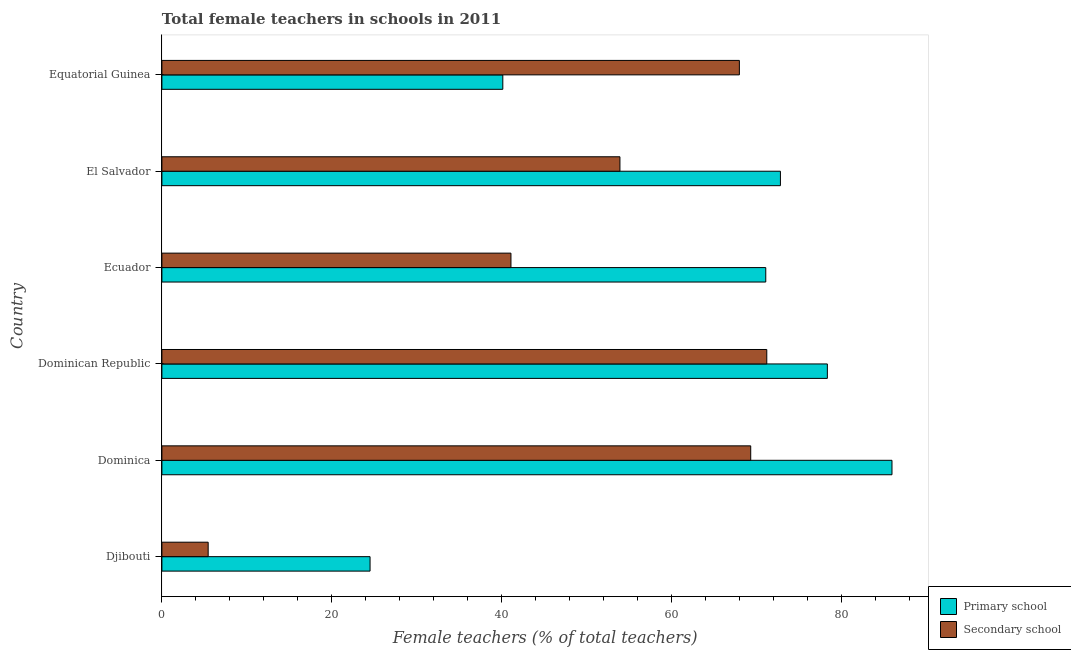How many different coloured bars are there?
Keep it short and to the point. 2. Are the number of bars on each tick of the Y-axis equal?
Your answer should be very brief. Yes. What is the label of the 2nd group of bars from the top?
Ensure brevity in your answer.  El Salvador. What is the percentage of female teachers in secondary schools in Equatorial Guinea?
Make the answer very short. 67.95. Across all countries, what is the maximum percentage of female teachers in primary schools?
Your answer should be compact. 85.91. Across all countries, what is the minimum percentage of female teachers in primary schools?
Provide a succinct answer. 24.49. In which country was the percentage of female teachers in secondary schools maximum?
Make the answer very short. Dominican Republic. In which country was the percentage of female teachers in secondary schools minimum?
Your response must be concise. Djibouti. What is the total percentage of female teachers in primary schools in the graph?
Offer a very short reply. 372.67. What is the difference between the percentage of female teachers in primary schools in Dominica and that in Equatorial Guinea?
Offer a terse response. 45.79. What is the difference between the percentage of female teachers in primary schools in Dominican Republic and the percentage of female teachers in secondary schools in Djibouti?
Make the answer very short. 72.86. What is the average percentage of female teachers in secondary schools per country?
Your answer should be very brief. 51.47. What is the difference between the percentage of female teachers in secondary schools and percentage of female teachers in primary schools in Equatorial Guinea?
Ensure brevity in your answer.  27.84. In how many countries, is the percentage of female teachers in primary schools greater than 44 %?
Provide a short and direct response. 4. What is the ratio of the percentage of female teachers in primary schools in Dominican Republic to that in Equatorial Guinea?
Provide a succinct answer. 1.95. What is the difference between the highest and the second highest percentage of female teachers in primary schools?
Your response must be concise. 7.61. What is the difference between the highest and the lowest percentage of female teachers in secondary schools?
Your response must be concise. 65.73. Is the sum of the percentage of female teachers in primary schools in Djibouti and El Salvador greater than the maximum percentage of female teachers in secondary schools across all countries?
Offer a terse response. Yes. What does the 1st bar from the top in Dominican Republic represents?
Keep it short and to the point. Secondary school. What does the 2nd bar from the bottom in Djibouti represents?
Your response must be concise. Secondary school. What is the difference between two consecutive major ticks on the X-axis?
Provide a short and direct response. 20. Does the graph contain grids?
Your response must be concise. No. What is the title of the graph?
Your answer should be compact. Total female teachers in schools in 2011. Does "Food and tobacco" appear as one of the legend labels in the graph?
Provide a short and direct response. No. What is the label or title of the X-axis?
Ensure brevity in your answer.  Female teachers (% of total teachers). What is the Female teachers (% of total teachers) in Primary school in Djibouti?
Provide a short and direct response. 24.49. What is the Female teachers (% of total teachers) of Secondary school in Djibouti?
Provide a short and direct response. 5.44. What is the Female teachers (% of total teachers) in Primary school in Dominica?
Offer a terse response. 85.91. What is the Female teachers (% of total teachers) of Secondary school in Dominica?
Ensure brevity in your answer.  69.29. What is the Female teachers (% of total teachers) in Primary school in Dominican Republic?
Your answer should be very brief. 78.31. What is the Female teachers (% of total teachers) of Secondary school in Dominican Republic?
Your response must be concise. 71.18. What is the Female teachers (% of total teachers) in Primary school in Ecuador?
Your response must be concise. 71.06. What is the Female teachers (% of total teachers) in Secondary school in Ecuador?
Offer a terse response. 41.07. What is the Female teachers (% of total teachers) of Primary school in El Salvador?
Ensure brevity in your answer.  72.78. What is the Female teachers (% of total teachers) of Secondary school in El Salvador?
Give a very brief answer. 53.9. What is the Female teachers (% of total teachers) in Primary school in Equatorial Guinea?
Your answer should be very brief. 40.12. What is the Female teachers (% of total teachers) in Secondary school in Equatorial Guinea?
Keep it short and to the point. 67.95. Across all countries, what is the maximum Female teachers (% of total teachers) in Primary school?
Provide a succinct answer. 85.91. Across all countries, what is the maximum Female teachers (% of total teachers) of Secondary school?
Make the answer very short. 71.18. Across all countries, what is the minimum Female teachers (% of total teachers) of Primary school?
Offer a terse response. 24.49. Across all countries, what is the minimum Female teachers (% of total teachers) in Secondary school?
Provide a short and direct response. 5.44. What is the total Female teachers (% of total teachers) of Primary school in the graph?
Make the answer very short. 372.67. What is the total Female teachers (% of total teachers) of Secondary school in the graph?
Provide a succinct answer. 308.83. What is the difference between the Female teachers (% of total teachers) in Primary school in Djibouti and that in Dominica?
Offer a very short reply. -61.42. What is the difference between the Female teachers (% of total teachers) in Secondary school in Djibouti and that in Dominica?
Your answer should be compact. -63.84. What is the difference between the Female teachers (% of total teachers) in Primary school in Djibouti and that in Dominican Republic?
Make the answer very short. -53.81. What is the difference between the Female teachers (% of total teachers) of Secondary school in Djibouti and that in Dominican Republic?
Your response must be concise. -65.73. What is the difference between the Female teachers (% of total teachers) of Primary school in Djibouti and that in Ecuador?
Provide a short and direct response. -46.56. What is the difference between the Female teachers (% of total teachers) of Secondary school in Djibouti and that in Ecuador?
Keep it short and to the point. -35.63. What is the difference between the Female teachers (% of total teachers) in Primary school in Djibouti and that in El Salvador?
Make the answer very short. -48.29. What is the difference between the Female teachers (% of total teachers) of Secondary school in Djibouti and that in El Salvador?
Offer a terse response. -48.45. What is the difference between the Female teachers (% of total teachers) of Primary school in Djibouti and that in Equatorial Guinea?
Offer a very short reply. -15.62. What is the difference between the Female teachers (% of total teachers) in Secondary school in Djibouti and that in Equatorial Guinea?
Provide a short and direct response. -62.51. What is the difference between the Female teachers (% of total teachers) of Primary school in Dominica and that in Dominican Republic?
Give a very brief answer. 7.6. What is the difference between the Female teachers (% of total teachers) of Secondary school in Dominica and that in Dominican Republic?
Your answer should be very brief. -1.89. What is the difference between the Female teachers (% of total teachers) in Primary school in Dominica and that in Ecuador?
Provide a short and direct response. 14.85. What is the difference between the Female teachers (% of total teachers) in Secondary school in Dominica and that in Ecuador?
Provide a succinct answer. 28.21. What is the difference between the Female teachers (% of total teachers) in Primary school in Dominica and that in El Salvador?
Make the answer very short. 13.13. What is the difference between the Female teachers (% of total teachers) of Secondary school in Dominica and that in El Salvador?
Ensure brevity in your answer.  15.39. What is the difference between the Female teachers (% of total teachers) of Primary school in Dominica and that in Equatorial Guinea?
Give a very brief answer. 45.79. What is the difference between the Female teachers (% of total teachers) in Secondary school in Dominica and that in Equatorial Guinea?
Provide a short and direct response. 1.33. What is the difference between the Female teachers (% of total teachers) of Primary school in Dominican Republic and that in Ecuador?
Your answer should be compact. 7.25. What is the difference between the Female teachers (% of total teachers) in Secondary school in Dominican Republic and that in Ecuador?
Ensure brevity in your answer.  30.1. What is the difference between the Female teachers (% of total teachers) of Primary school in Dominican Republic and that in El Salvador?
Keep it short and to the point. 5.52. What is the difference between the Female teachers (% of total teachers) of Secondary school in Dominican Republic and that in El Salvador?
Give a very brief answer. 17.28. What is the difference between the Female teachers (% of total teachers) of Primary school in Dominican Republic and that in Equatorial Guinea?
Offer a terse response. 38.19. What is the difference between the Female teachers (% of total teachers) of Secondary school in Dominican Republic and that in Equatorial Guinea?
Keep it short and to the point. 3.22. What is the difference between the Female teachers (% of total teachers) of Primary school in Ecuador and that in El Salvador?
Your response must be concise. -1.72. What is the difference between the Female teachers (% of total teachers) in Secondary school in Ecuador and that in El Salvador?
Give a very brief answer. -12.82. What is the difference between the Female teachers (% of total teachers) in Primary school in Ecuador and that in Equatorial Guinea?
Provide a succinct answer. 30.94. What is the difference between the Female teachers (% of total teachers) in Secondary school in Ecuador and that in Equatorial Guinea?
Provide a short and direct response. -26.88. What is the difference between the Female teachers (% of total teachers) of Primary school in El Salvador and that in Equatorial Guinea?
Your response must be concise. 32.67. What is the difference between the Female teachers (% of total teachers) of Secondary school in El Salvador and that in Equatorial Guinea?
Keep it short and to the point. -14.05. What is the difference between the Female teachers (% of total teachers) of Primary school in Djibouti and the Female teachers (% of total teachers) of Secondary school in Dominica?
Offer a terse response. -44.79. What is the difference between the Female teachers (% of total teachers) in Primary school in Djibouti and the Female teachers (% of total teachers) in Secondary school in Dominican Republic?
Your answer should be compact. -46.68. What is the difference between the Female teachers (% of total teachers) in Primary school in Djibouti and the Female teachers (% of total teachers) in Secondary school in Ecuador?
Offer a terse response. -16.58. What is the difference between the Female teachers (% of total teachers) of Primary school in Djibouti and the Female teachers (% of total teachers) of Secondary school in El Salvador?
Make the answer very short. -29.4. What is the difference between the Female teachers (% of total teachers) in Primary school in Djibouti and the Female teachers (% of total teachers) in Secondary school in Equatorial Guinea?
Your answer should be very brief. -43.46. What is the difference between the Female teachers (% of total teachers) in Primary school in Dominica and the Female teachers (% of total teachers) in Secondary school in Dominican Republic?
Provide a succinct answer. 14.73. What is the difference between the Female teachers (% of total teachers) in Primary school in Dominica and the Female teachers (% of total teachers) in Secondary school in Ecuador?
Provide a succinct answer. 44.84. What is the difference between the Female teachers (% of total teachers) of Primary school in Dominica and the Female teachers (% of total teachers) of Secondary school in El Salvador?
Make the answer very short. 32.01. What is the difference between the Female teachers (% of total teachers) in Primary school in Dominica and the Female teachers (% of total teachers) in Secondary school in Equatorial Guinea?
Your answer should be very brief. 17.96. What is the difference between the Female teachers (% of total teachers) in Primary school in Dominican Republic and the Female teachers (% of total teachers) in Secondary school in Ecuador?
Keep it short and to the point. 37.23. What is the difference between the Female teachers (% of total teachers) of Primary school in Dominican Republic and the Female teachers (% of total teachers) of Secondary school in El Salvador?
Your answer should be compact. 24.41. What is the difference between the Female teachers (% of total teachers) in Primary school in Dominican Republic and the Female teachers (% of total teachers) in Secondary school in Equatorial Guinea?
Ensure brevity in your answer.  10.35. What is the difference between the Female teachers (% of total teachers) in Primary school in Ecuador and the Female teachers (% of total teachers) in Secondary school in El Salvador?
Your answer should be very brief. 17.16. What is the difference between the Female teachers (% of total teachers) in Primary school in Ecuador and the Female teachers (% of total teachers) in Secondary school in Equatorial Guinea?
Offer a very short reply. 3.11. What is the difference between the Female teachers (% of total teachers) in Primary school in El Salvador and the Female teachers (% of total teachers) in Secondary school in Equatorial Guinea?
Offer a terse response. 4.83. What is the average Female teachers (% of total teachers) in Primary school per country?
Ensure brevity in your answer.  62.11. What is the average Female teachers (% of total teachers) of Secondary school per country?
Keep it short and to the point. 51.47. What is the difference between the Female teachers (% of total teachers) in Primary school and Female teachers (% of total teachers) in Secondary school in Djibouti?
Ensure brevity in your answer.  19.05. What is the difference between the Female teachers (% of total teachers) of Primary school and Female teachers (% of total teachers) of Secondary school in Dominica?
Offer a very short reply. 16.62. What is the difference between the Female teachers (% of total teachers) in Primary school and Female teachers (% of total teachers) in Secondary school in Dominican Republic?
Make the answer very short. 7.13. What is the difference between the Female teachers (% of total teachers) of Primary school and Female teachers (% of total teachers) of Secondary school in Ecuador?
Ensure brevity in your answer.  29.99. What is the difference between the Female teachers (% of total teachers) in Primary school and Female teachers (% of total teachers) in Secondary school in El Salvador?
Keep it short and to the point. 18.88. What is the difference between the Female teachers (% of total teachers) in Primary school and Female teachers (% of total teachers) in Secondary school in Equatorial Guinea?
Your answer should be very brief. -27.84. What is the ratio of the Female teachers (% of total teachers) in Primary school in Djibouti to that in Dominica?
Your answer should be very brief. 0.29. What is the ratio of the Female teachers (% of total teachers) of Secondary school in Djibouti to that in Dominica?
Ensure brevity in your answer.  0.08. What is the ratio of the Female teachers (% of total teachers) in Primary school in Djibouti to that in Dominican Republic?
Your response must be concise. 0.31. What is the ratio of the Female teachers (% of total teachers) of Secondary school in Djibouti to that in Dominican Republic?
Make the answer very short. 0.08. What is the ratio of the Female teachers (% of total teachers) of Primary school in Djibouti to that in Ecuador?
Offer a terse response. 0.34. What is the ratio of the Female teachers (% of total teachers) of Secondary school in Djibouti to that in Ecuador?
Offer a terse response. 0.13. What is the ratio of the Female teachers (% of total teachers) of Primary school in Djibouti to that in El Salvador?
Your answer should be very brief. 0.34. What is the ratio of the Female teachers (% of total teachers) in Secondary school in Djibouti to that in El Salvador?
Offer a very short reply. 0.1. What is the ratio of the Female teachers (% of total teachers) in Primary school in Djibouti to that in Equatorial Guinea?
Make the answer very short. 0.61. What is the ratio of the Female teachers (% of total teachers) of Secondary school in Djibouti to that in Equatorial Guinea?
Make the answer very short. 0.08. What is the ratio of the Female teachers (% of total teachers) of Primary school in Dominica to that in Dominican Republic?
Offer a terse response. 1.1. What is the ratio of the Female teachers (% of total teachers) of Secondary school in Dominica to that in Dominican Republic?
Your response must be concise. 0.97. What is the ratio of the Female teachers (% of total teachers) in Primary school in Dominica to that in Ecuador?
Provide a succinct answer. 1.21. What is the ratio of the Female teachers (% of total teachers) of Secondary school in Dominica to that in Ecuador?
Provide a succinct answer. 1.69. What is the ratio of the Female teachers (% of total teachers) in Primary school in Dominica to that in El Salvador?
Provide a succinct answer. 1.18. What is the ratio of the Female teachers (% of total teachers) in Secondary school in Dominica to that in El Salvador?
Provide a succinct answer. 1.29. What is the ratio of the Female teachers (% of total teachers) in Primary school in Dominica to that in Equatorial Guinea?
Ensure brevity in your answer.  2.14. What is the ratio of the Female teachers (% of total teachers) in Secondary school in Dominica to that in Equatorial Guinea?
Provide a succinct answer. 1.02. What is the ratio of the Female teachers (% of total teachers) of Primary school in Dominican Republic to that in Ecuador?
Offer a very short reply. 1.1. What is the ratio of the Female teachers (% of total teachers) in Secondary school in Dominican Republic to that in Ecuador?
Keep it short and to the point. 1.73. What is the ratio of the Female teachers (% of total teachers) of Primary school in Dominican Republic to that in El Salvador?
Offer a very short reply. 1.08. What is the ratio of the Female teachers (% of total teachers) in Secondary school in Dominican Republic to that in El Salvador?
Offer a terse response. 1.32. What is the ratio of the Female teachers (% of total teachers) of Primary school in Dominican Republic to that in Equatorial Guinea?
Provide a succinct answer. 1.95. What is the ratio of the Female teachers (% of total teachers) of Secondary school in Dominican Republic to that in Equatorial Guinea?
Keep it short and to the point. 1.05. What is the ratio of the Female teachers (% of total teachers) in Primary school in Ecuador to that in El Salvador?
Your answer should be compact. 0.98. What is the ratio of the Female teachers (% of total teachers) in Secondary school in Ecuador to that in El Salvador?
Your answer should be compact. 0.76. What is the ratio of the Female teachers (% of total teachers) of Primary school in Ecuador to that in Equatorial Guinea?
Provide a succinct answer. 1.77. What is the ratio of the Female teachers (% of total teachers) of Secondary school in Ecuador to that in Equatorial Guinea?
Your response must be concise. 0.6. What is the ratio of the Female teachers (% of total teachers) in Primary school in El Salvador to that in Equatorial Guinea?
Ensure brevity in your answer.  1.81. What is the ratio of the Female teachers (% of total teachers) in Secondary school in El Salvador to that in Equatorial Guinea?
Your response must be concise. 0.79. What is the difference between the highest and the second highest Female teachers (% of total teachers) in Primary school?
Offer a terse response. 7.6. What is the difference between the highest and the second highest Female teachers (% of total teachers) of Secondary school?
Ensure brevity in your answer.  1.89. What is the difference between the highest and the lowest Female teachers (% of total teachers) in Primary school?
Offer a terse response. 61.42. What is the difference between the highest and the lowest Female teachers (% of total teachers) of Secondary school?
Provide a succinct answer. 65.73. 